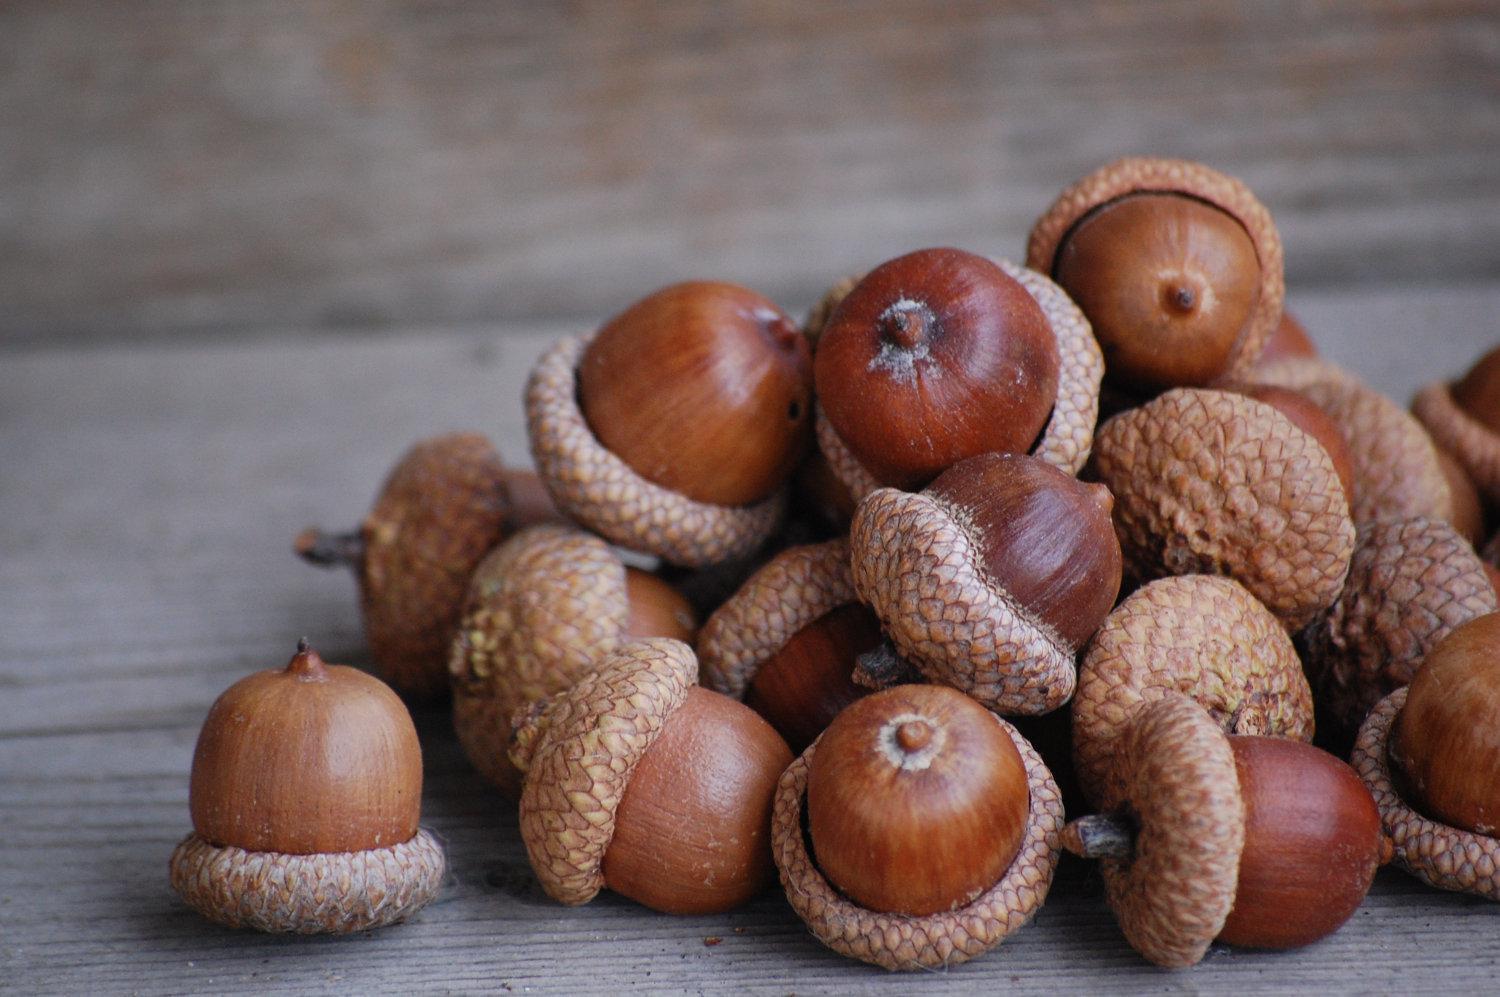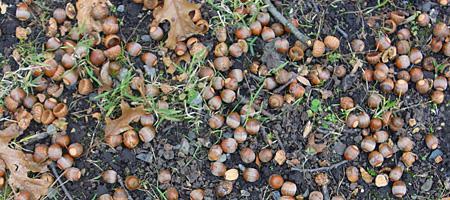The first image is the image on the left, the second image is the image on the right. Considering the images on both sides, is "There are acorns laying in the dirt." valid? Answer yes or no. Yes. The first image is the image on the left, the second image is the image on the right. Considering the images on both sides, is "There are at least 30 acorn bottoms sitting in the dirt with very little grass." valid? Answer yes or no. Yes. 